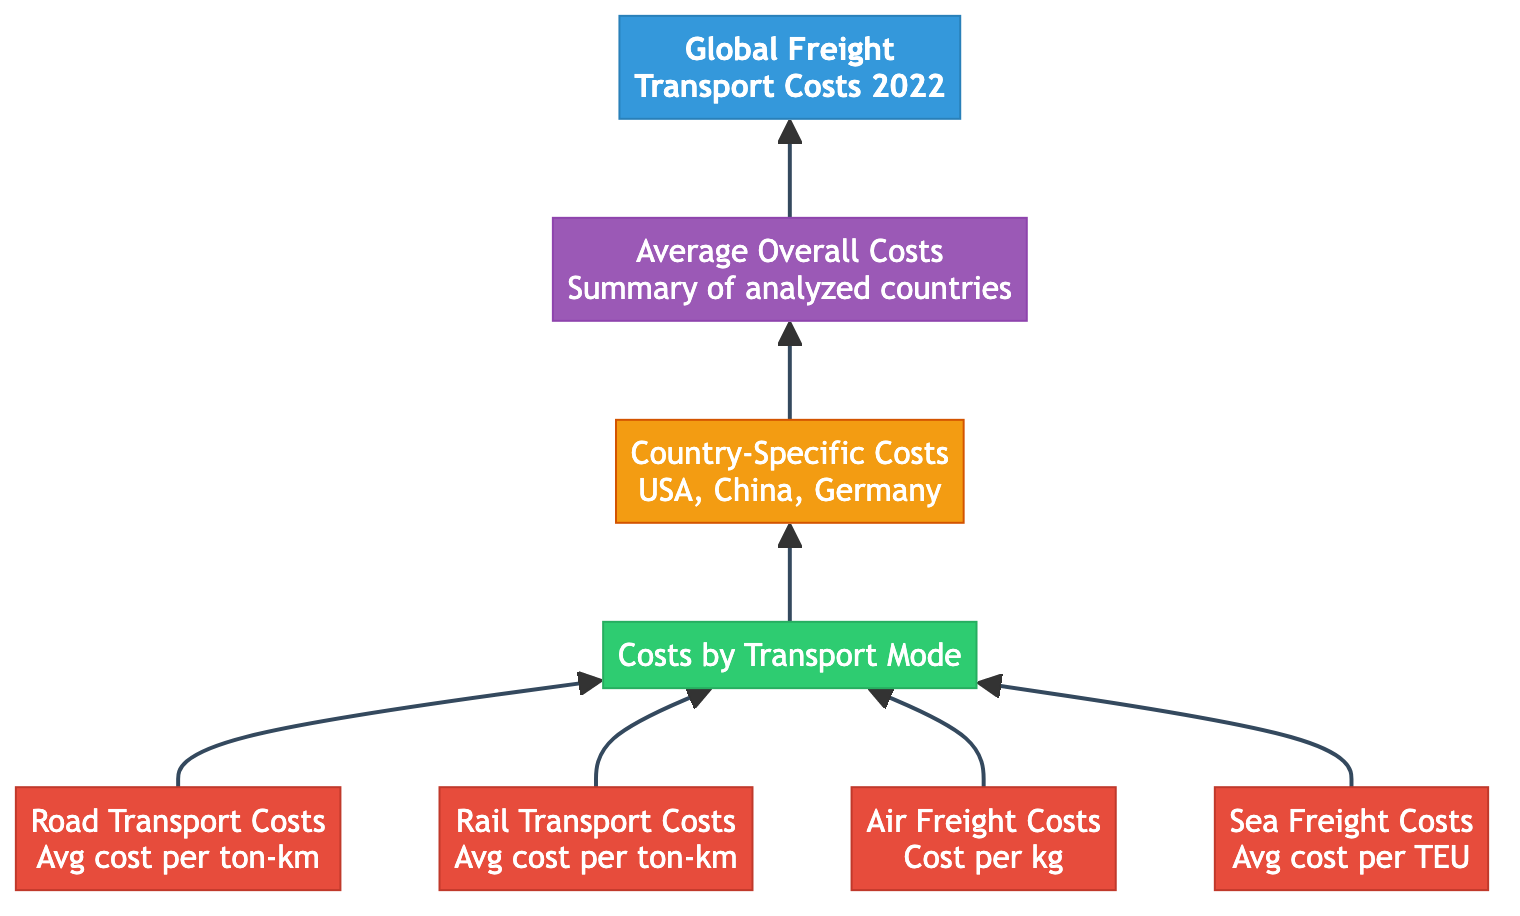What is the main category represented in the diagram? The diagram starts with the node labeled "Global Freight Transport Costs" which represents the overall theme of the diagram. This is the first node and therefore indicates the main category.
Answer: Global Freight Transport Costs How many subcategories are present in the diagram? The diagram has one subcategory node labeled "Costs by Transport Mode," which connects to multiple detail nodes representing different transport modes. That means the count of the subcategory is one.
Answer: 1 Which transport mode costs the least, according to the diagram? The diagram does not provide specific numerical values for the costs associated with each transport mode, thus making it impossible to distinguish directly between them based on the provided structure. However, one could infer based on common knowledge or further analysis but not from the diagram itself.
Answer: Not determinable What type of costs are detailed under "Country-Specific Costs"? The node labeled "Country-Specific Costs" specifically mentions comparisons for countries like the USA, China, and Germany, implying that it refers to freight transport costs within those countries.
Answer: USA, China, Germany What connects the "Country-Specific Costs" node to the next stage in the diagram? The flow from the "Country-Specific Costs" node leads to the "Average Overall Costs" node, indicating that the country comparisons culminate in an average overview of costs. This directional arrow signifies a clear connection of the two nodes.
Answer: Average Overall Costs How is the information structured in this bottom-up flow chart? This type of diagram is structured hierarchically, starting with a broad category at the top, then breaking it down into subcategories and details, eventually summarizing in a conclusion. This flow represents a logical progression from general to specific.
Answer: Hierarchical structure Which node serves as an intermediary in the flow chart? The node labeled "Country-Specific Costs" acts as an intermediary between the subcategory and the conclusion, representing a critical step in breaking down costs before averaging them.
Answer: Country-Specific Costs What is the final conclusion drawn from the diagram? The node at the bottom of the flow chart, "Average Overall Costs," summarizes the freight costs analyzed, representing the conclusion of the data flow within the diagram.
Answer: Average Overall Costs 